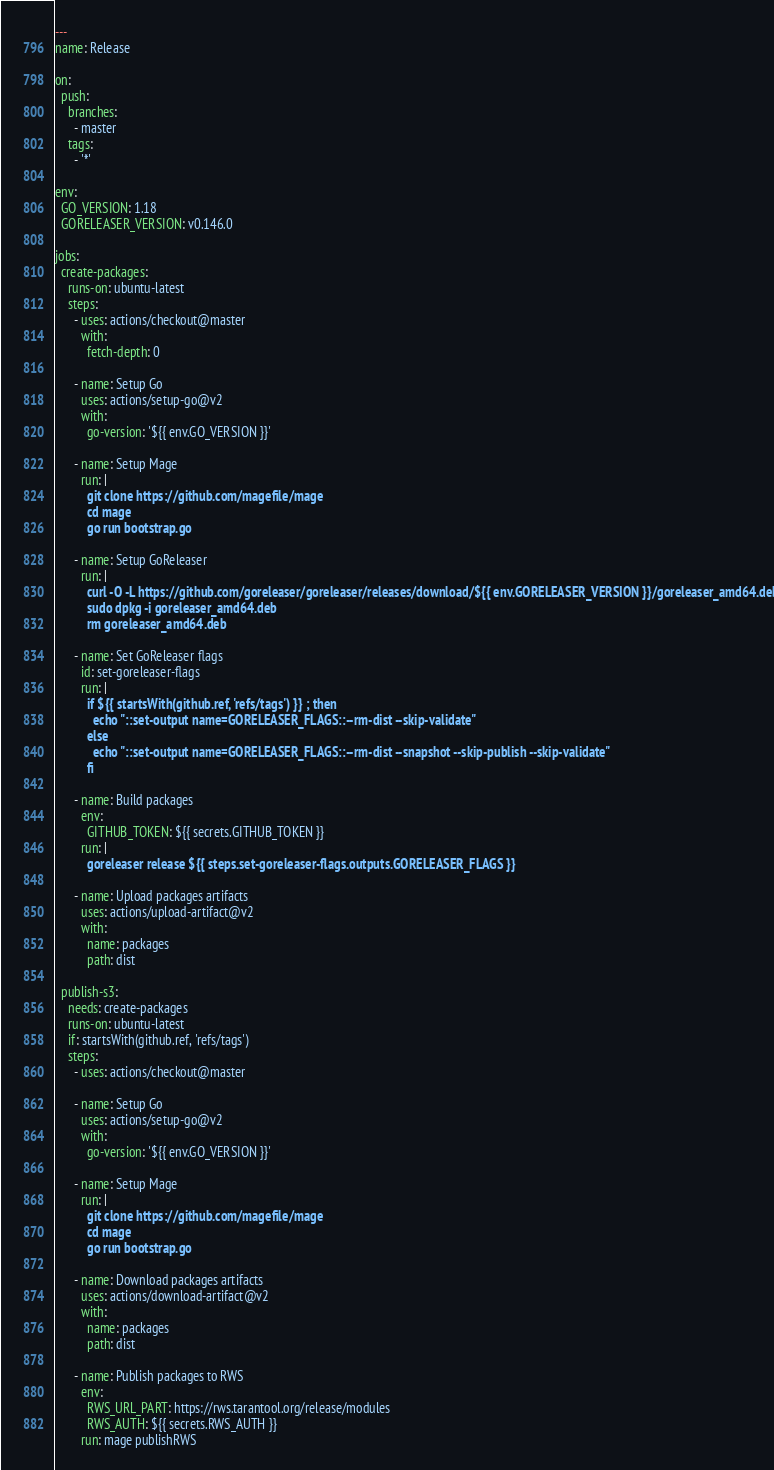<code> <loc_0><loc_0><loc_500><loc_500><_YAML_>---
name: Release

on:
  push:
    branches:
      - master
    tags:
      - '*'

env:
  GO_VERSION: 1.18
  GORELEASER_VERSION: v0.146.0

jobs:
  create-packages:
    runs-on: ubuntu-latest
    steps:
      - uses: actions/checkout@master
        with:
          fetch-depth: 0

      - name: Setup Go
        uses: actions/setup-go@v2
        with:
          go-version: '${{ env.GO_VERSION }}'

      - name: Setup Mage
        run: |
          git clone https://github.com/magefile/mage
          cd mage
          go run bootstrap.go

      - name: Setup GoReleaser
        run: |
          curl -O -L https://github.com/goreleaser/goreleaser/releases/download/${{ env.GORELEASER_VERSION }}/goreleaser_amd64.deb
          sudo dpkg -i goreleaser_amd64.deb
          rm goreleaser_amd64.deb

      - name: Set GoReleaser flags
        id: set-goreleaser-flags
        run: |
          if ${{ startsWith(github.ref, 'refs/tags') }} ; then
            echo "::set-output name=GORELEASER_FLAGS::--rm-dist --skip-validate"
          else
            echo "::set-output name=GORELEASER_FLAGS::--rm-dist --snapshot --skip-publish --skip-validate"
          fi

      - name: Build packages
        env:
          GITHUB_TOKEN: ${{ secrets.GITHUB_TOKEN }}
        run: |
          goreleaser release ${{ steps.set-goreleaser-flags.outputs.GORELEASER_FLAGS }}

      - name: Upload packages artifacts
        uses: actions/upload-artifact@v2
        with:
          name: packages
          path: dist

  publish-s3:
    needs: create-packages
    runs-on: ubuntu-latest
    if: startsWith(github.ref, 'refs/tags')
    steps:
      - uses: actions/checkout@master

      - name: Setup Go
        uses: actions/setup-go@v2
        with:
          go-version: '${{ env.GO_VERSION }}'

      - name: Setup Mage
        run: |
          git clone https://github.com/magefile/mage
          cd mage
          go run bootstrap.go

      - name: Download packages artifacts
        uses: actions/download-artifact@v2
        with:
          name: packages
          path: dist

      - name: Publish packages to RWS
        env:
          RWS_URL_PART: https://rws.tarantool.org/release/modules
          RWS_AUTH: ${{ secrets.RWS_AUTH }}
        run: mage publishRWS
</code> 